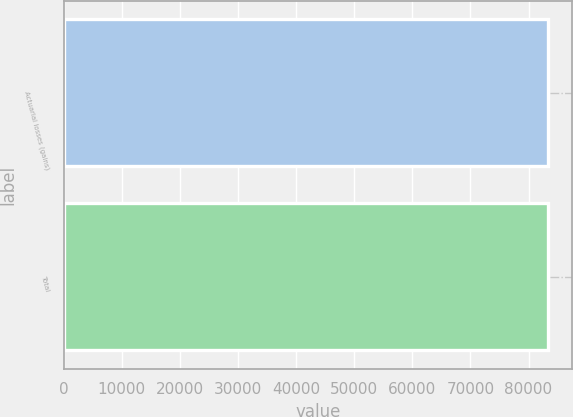Convert chart. <chart><loc_0><loc_0><loc_500><loc_500><bar_chart><fcel>Actuarial losses (gains)<fcel>Total<nl><fcel>83347<fcel>83347.1<nl></chart> 